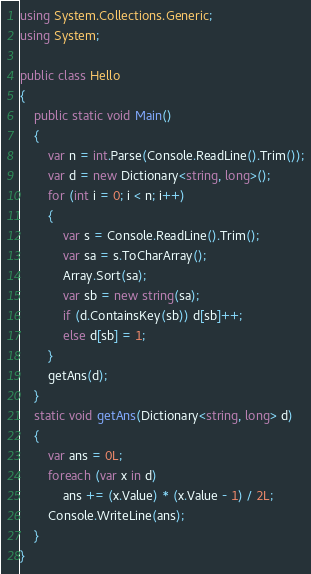<code> <loc_0><loc_0><loc_500><loc_500><_C#_>using System.Collections.Generic;
using System;

public class Hello
{
	public static void Main()
	{
		var n = int.Parse(Console.ReadLine().Trim());
		var d = new Dictionary<string, long>();
		for (int i = 0; i < n; i++)
		{
			var s = Console.ReadLine().Trim();
			var sa = s.ToCharArray();
			Array.Sort(sa);
			var sb = new string(sa);
			if (d.ContainsKey(sb)) d[sb]++;
			else d[sb] = 1;
		}
		getAns(d);
	}
	static void getAns(Dictionary<string, long> d)
	{
		var ans = 0L;
		foreach (var x in d)
			ans += (x.Value) * (x.Value - 1) / 2L;
		Console.WriteLine(ans);
	}
}</code> 